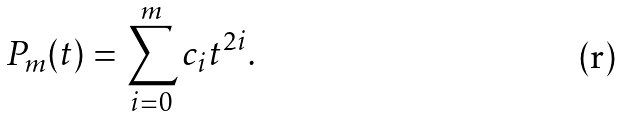<formula> <loc_0><loc_0><loc_500><loc_500>P _ { m } ( t ) = \sum _ { i = 0 } ^ { m } c _ { i } t ^ { 2 i } .</formula> 